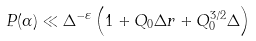<formula> <loc_0><loc_0><loc_500><loc_500>P ( \alpha ) \ll \Delta ^ { - \varepsilon } \left ( 1 + Q _ { 0 } \Delta r + Q _ { 0 } ^ { 3 / 2 } \Delta \right )</formula> 